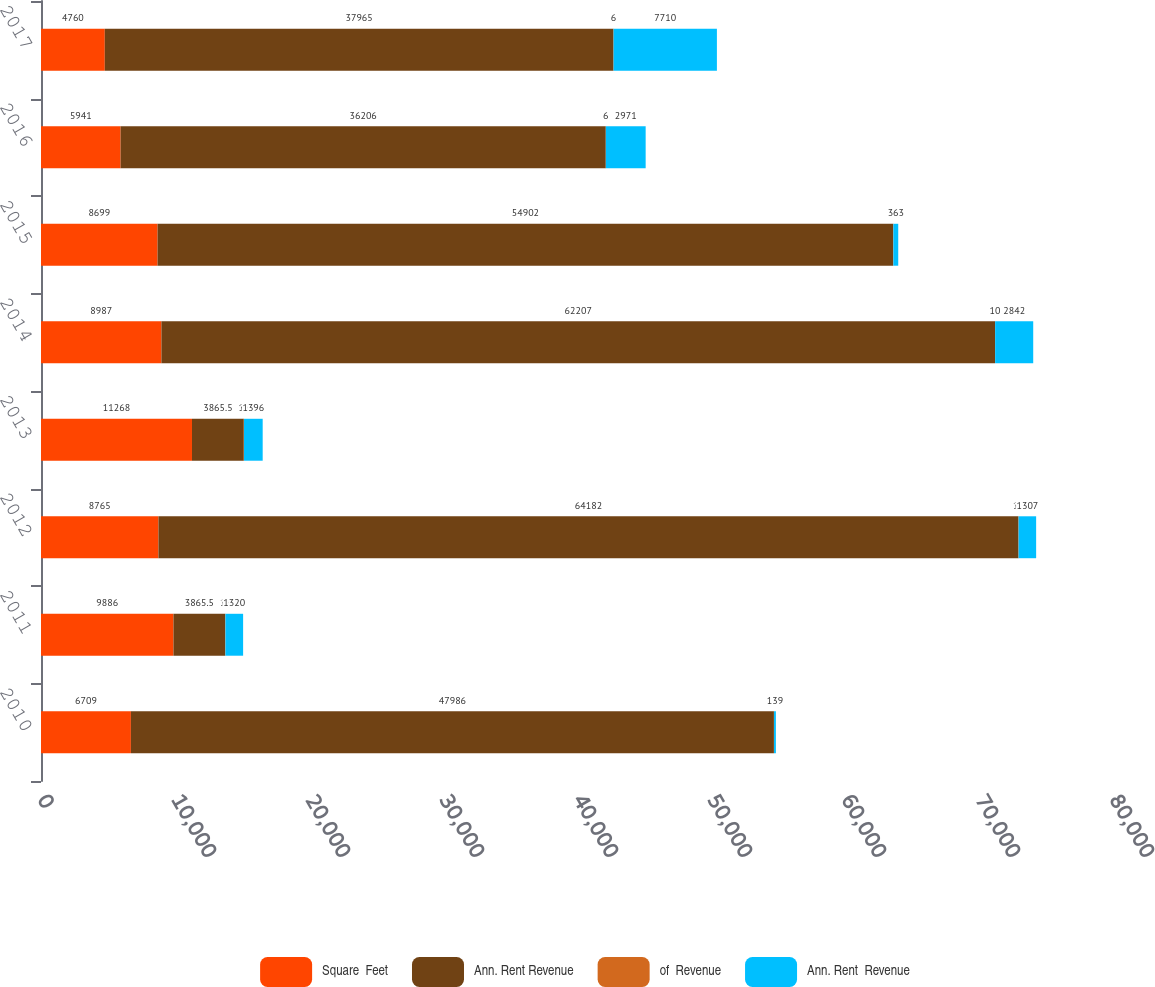Convert chart. <chart><loc_0><loc_0><loc_500><loc_500><stacked_bar_chart><ecel><fcel>2010<fcel>2011<fcel>2012<fcel>2013<fcel>2014<fcel>2015<fcel>2016<fcel>2017<nl><fcel>Square  Feet<fcel>6709<fcel>9886<fcel>8765<fcel>11268<fcel>8987<fcel>8699<fcel>5941<fcel>4760<nl><fcel>Ann. Rent Revenue<fcel>47986<fcel>3865.5<fcel>64182<fcel>3865.5<fcel>62207<fcel>54902<fcel>36206<fcel>37965<nl><fcel>of  Revenue<fcel>8<fcel>12<fcel>10<fcel>14<fcel>10<fcel>9<fcel>6<fcel>6<nl><fcel>Ann. Rent  Revenue<fcel>139<fcel>1320<fcel>1307<fcel>1396<fcel>2842<fcel>363<fcel>2971<fcel>7710<nl></chart> 